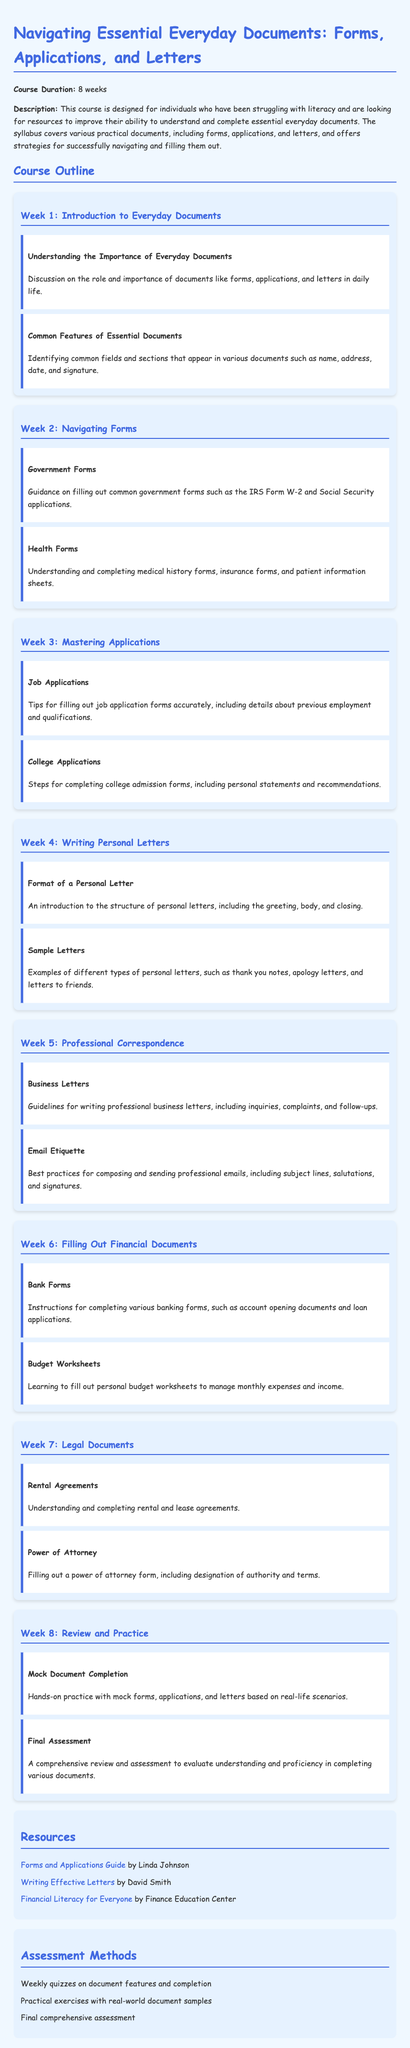what is the course duration? The course is designed to last for a total of 8 weeks.
Answer: 8 weeks who is the author of the "Forms and Applications Guide"? The document references Linda Johnson as the author of this guide.
Answer: Linda Johnson what types of applications are covered in week 3? The focus in week 3 includes job applications and college applications.
Answer: Job Applications, College Applications what is the main purpose of the course? The course aims to provide individuals with resources to improve their literacy in handling essential documents.
Answer: Improve literacy how many assessment methods are listed in the syllabus? There are three assessment methods outlined in the assessment section of the document.
Answer: 3 what type of letter is discussed in week 4? Week 4 introduces the format of personal letters, including various examples.
Answer: Personal letters which week covers financial documents? Week 6 specifically addresses the topic of filling out financial documents.
Answer: Week 6 what is one of the resources provided in the syllabus? The syllabus includes a guide titled "Writing Effective Letters" by David Smith as one of the resources.
Answer: Writing Effective Letters what is included in the final week of the course? The final week of the course is dedicated to a review and practice of the skills learned throughout the course.
Answer: Review and practice 